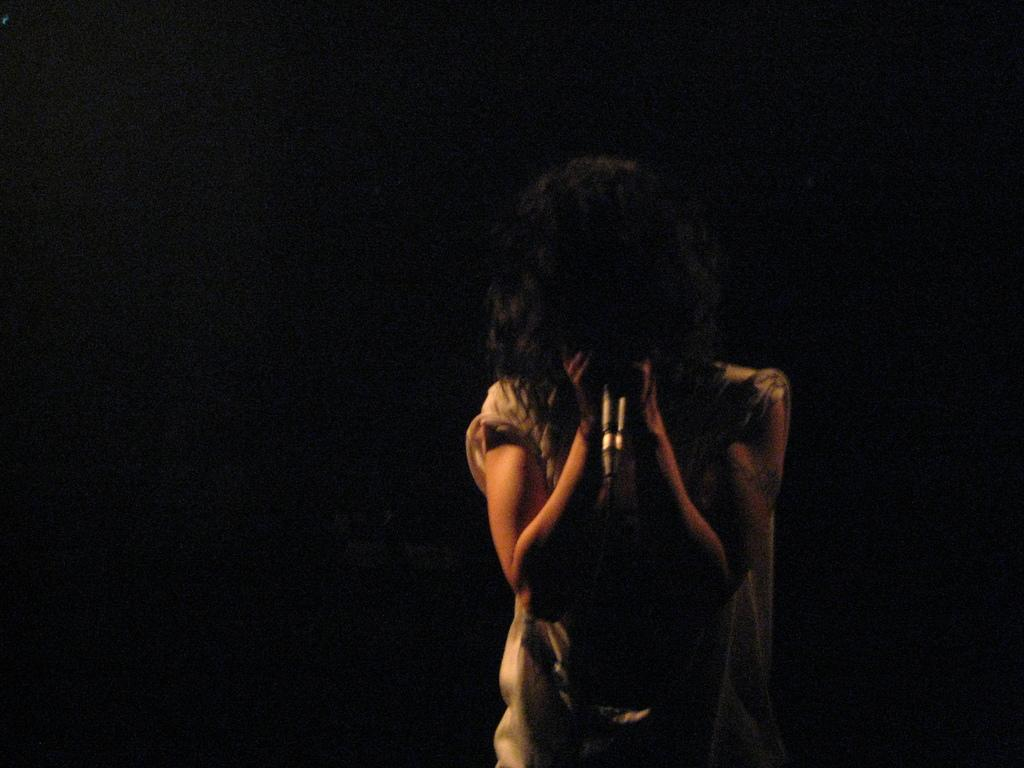Who is the main subject in the image? There is a lady in the image. What is the lady holding in her hand? The lady is holding a mic in her hand. Can you describe the background of the image? The background of the image is dark. What type of bottle is the lady using to cook in the image? There is no bottle or cooking activity present in the image. How many songs can be heard being sung by the lady in the image? There is no audio or indication of singing in the image. 